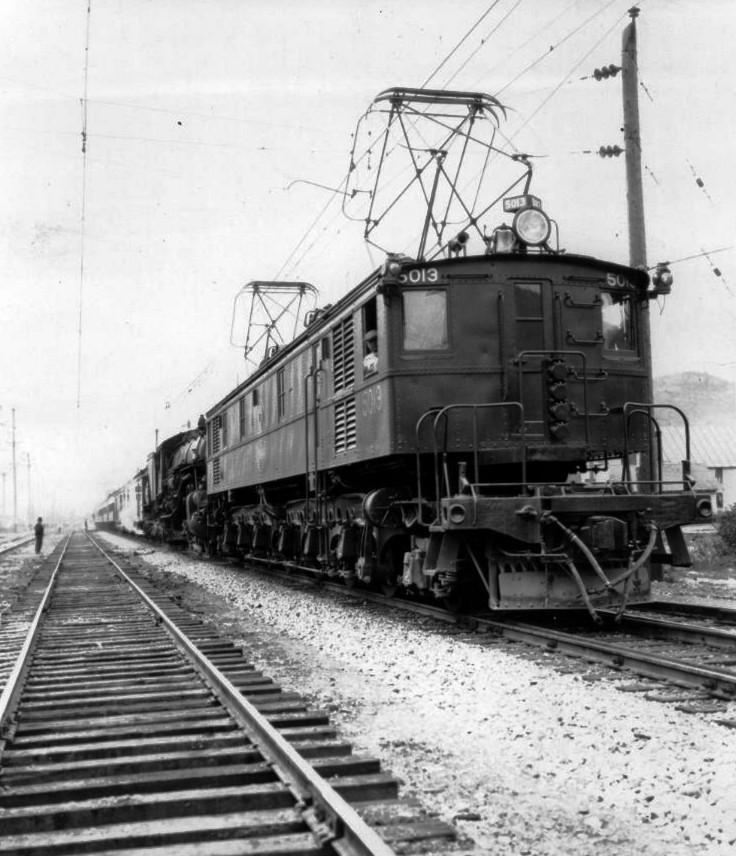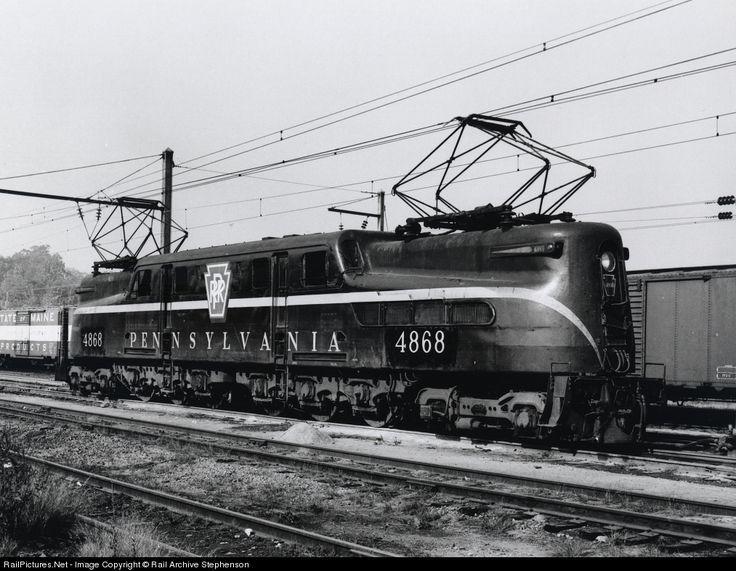The first image is the image on the left, the second image is the image on the right. For the images displayed, is the sentence "All trains are heading to the right." factually correct? Answer yes or no. Yes. The first image is the image on the left, the second image is the image on the right. Analyze the images presented: Is the assertion "An image shows a train with a rounded front and a stripe that curves up from the bottom of the front to run along the side, and geometric 3D frames are above the train." valid? Answer yes or no. Yes. 